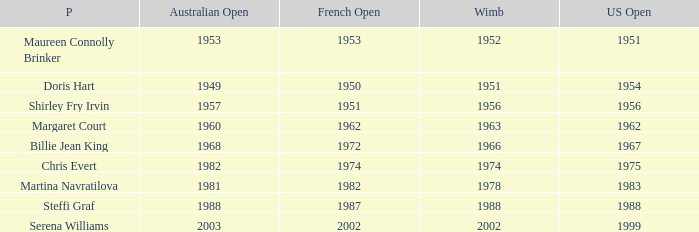What year did Martina Navratilova win Wimbledon? 1978.0. 